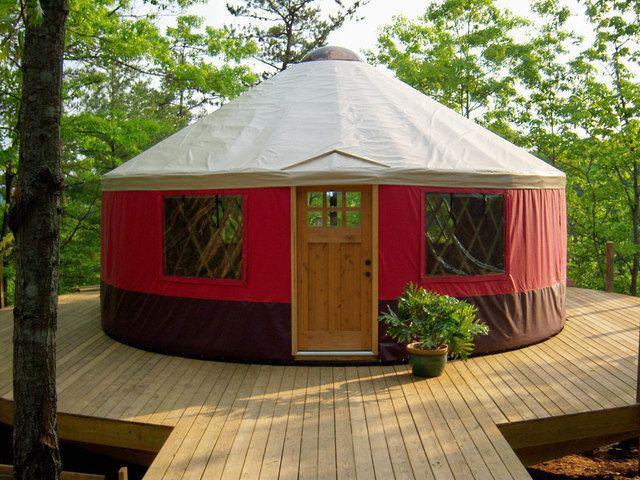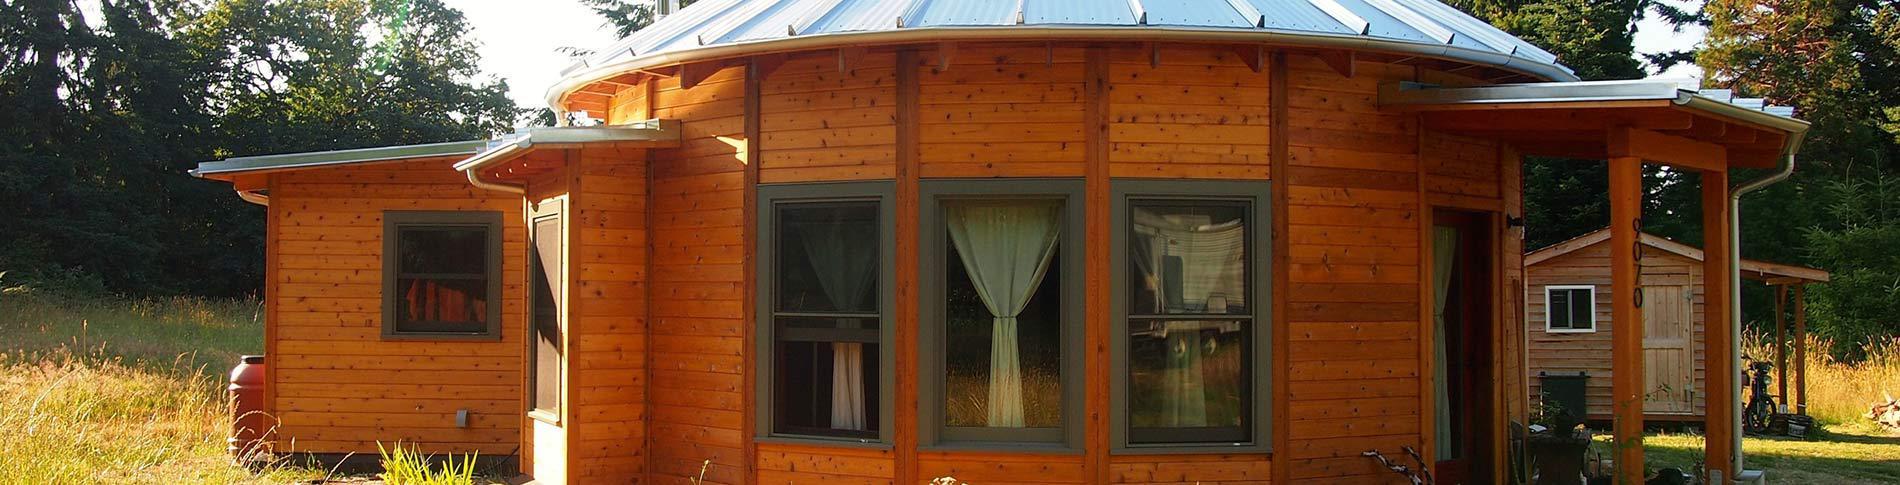The first image is the image on the left, the second image is the image on the right. Examine the images to the left and right. Is the description "There is at least one round window in the door in one of the images." accurate? Answer yes or no. No. 